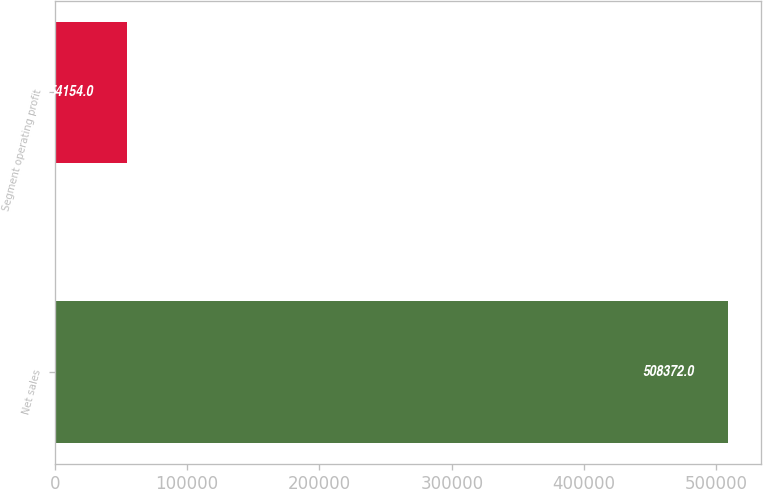Convert chart. <chart><loc_0><loc_0><loc_500><loc_500><bar_chart><fcel>Net sales<fcel>Segment operating profit<nl><fcel>508372<fcel>54154<nl></chart> 